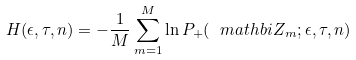<formula> <loc_0><loc_0><loc_500><loc_500>H ( \epsilon , \tau , n ) = - \frac { 1 } { M } \sum _ { m = 1 } ^ { M } \ln P _ { + } ( { \ m a t h b i Z } _ { m } ; \epsilon , \tau , n )</formula> 